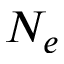Convert formula to latex. <formula><loc_0><loc_0><loc_500><loc_500>N _ { e }</formula> 